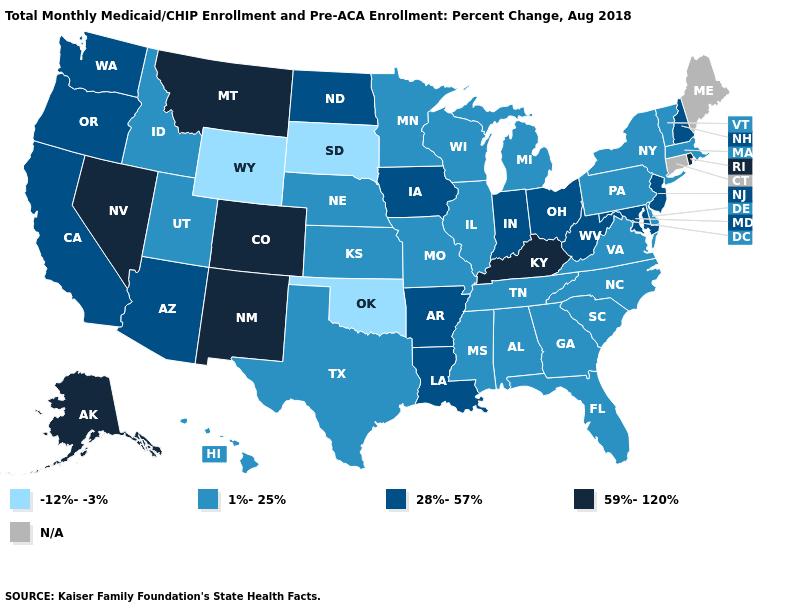What is the highest value in the USA?
Write a very short answer. 59%-120%. Name the states that have a value in the range 28%-57%?
Answer briefly. Arizona, Arkansas, California, Indiana, Iowa, Louisiana, Maryland, New Hampshire, New Jersey, North Dakota, Ohio, Oregon, Washington, West Virginia. What is the highest value in states that border Delaware?
Quick response, please. 28%-57%. What is the highest value in the West ?
Concise answer only. 59%-120%. What is the highest value in the MidWest ?
Answer briefly. 28%-57%. Among the states that border Georgia , which have the lowest value?
Give a very brief answer. Alabama, Florida, North Carolina, South Carolina, Tennessee. Which states have the lowest value in the West?
Write a very short answer. Wyoming. Does Colorado have the highest value in the USA?
Give a very brief answer. Yes. Does Mississippi have the lowest value in the South?
Keep it brief. No. What is the value of Washington?
Be succinct. 28%-57%. What is the lowest value in the MidWest?
Keep it brief. -12%--3%. Is the legend a continuous bar?
Concise answer only. No. What is the value of Georgia?
Quick response, please. 1%-25%. 